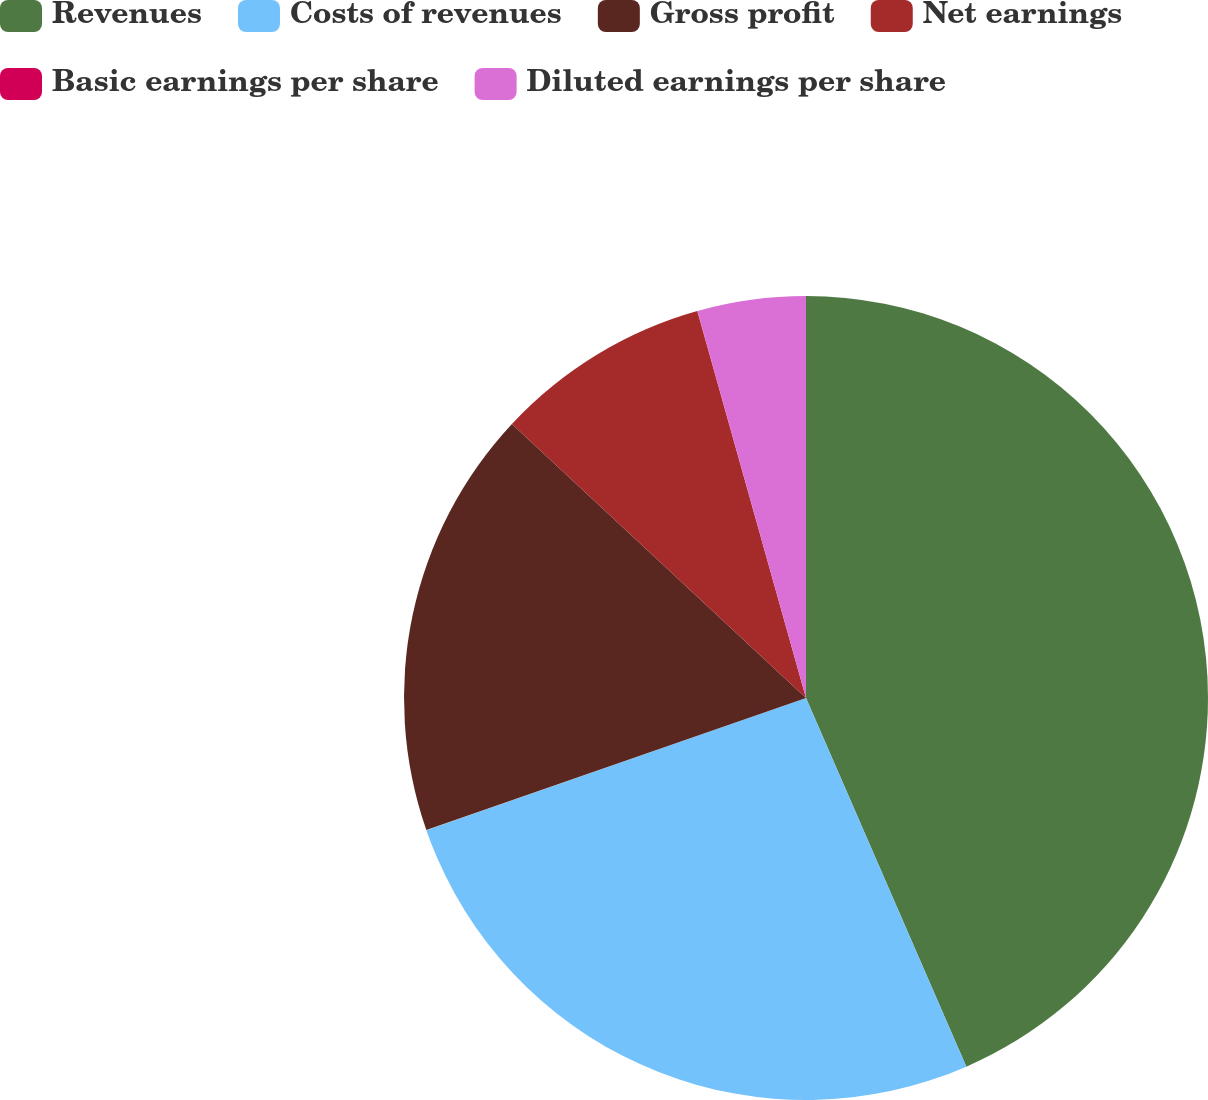<chart> <loc_0><loc_0><loc_500><loc_500><pie_chart><fcel>Revenues<fcel>Costs of revenues<fcel>Gross profit<fcel>Net earnings<fcel>Basic earnings per share<fcel>Diluted earnings per share<nl><fcel>43.47%<fcel>26.2%<fcel>17.27%<fcel>8.7%<fcel>0.01%<fcel>4.35%<nl></chart> 